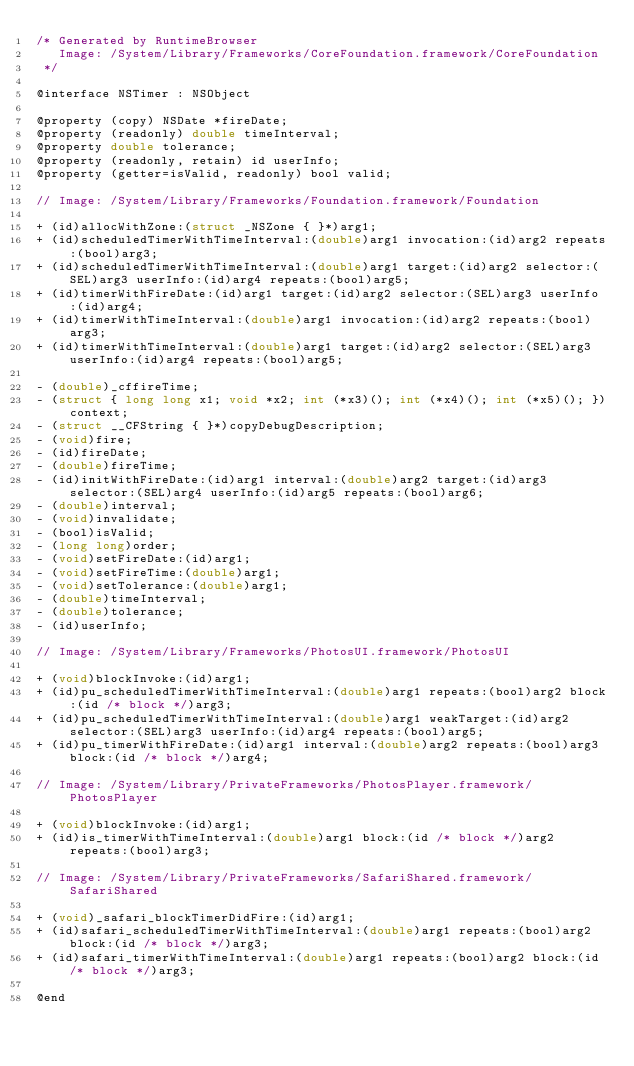<code> <loc_0><loc_0><loc_500><loc_500><_C_>/* Generated by RuntimeBrowser
   Image: /System/Library/Frameworks/CoreFoundation.framework/CoreFoundation
 */

@interface NSTimer : NSObject

@property (copy) NSDate *fireDate;
@property (readonly) double timeInterval;
@property double tolerance;
@property (readonly, retain) id userInfo;
@property (getter=isValid, readonly) bool valid;

// Image: /System/Library/Frameworks/Foundation.framework/Foundation

+ (id)allocWithZone:(struct _NSZone { }*)arg1;
+ (id)scheduledTimerWithTimeInterval:(double)arg1 invocation:(id)arg2 repeats:(bool)arg3;
+ (id)scheduledTimerWithTimeInterval:(double)arg1 target:(id)arg2 selector:(SEL)arg3 userInfo:(id)arg4 repeats:(bool)arg5;
+ (id)timerWithFireDate:(id)arg1 target:(id)arg2 selector:(SEL)arg3 userInfo:(id)arg4;
+ (id)timerWithTimeInterval:(double)arg1 invocation:(id)arg2 repeats:(bool)arg3;
+ (id)timerWithTimeInterval:(double)arg1 target:(id)arg2 selector:(SEL)arg3 userInfo:(id)arg4 repeats:(bool)arg5;

- (double)_cffireTime;
- (struct { long long x1; void *x2; int (*x3)(); int (*x4)(); int (*x5)(); })context;
- (struct __CFString { }*)copyDebugDescription;
- (void)fire;
- (id)fireDate;
- (double)fireTime;
- (id)initWithFireDate:(id)arg1 interval:(double)arg2 target:(id)arg3 selector:(SEL)arg4 userInfo:(id)arg5 repeats:(bool)arg6;
- (double)interval;
- (void)invalidate;
- (bool)isValid;
- (long long)order;
- (void)setFireDate:(id)arg1;
- (void)setFireTime:(double)arg1;
- (void)setTolerance:(double)arg1;
- (double)timeInterval;
- (double)tolerance;
- (id)userInfo;

// Image: /System/Library/Frameworks/PhotosUI.framework/PhotosUI

+ (void)blockInvoke:(id)arg1;
+ (id)pu_scheduledTimerWithTimeInterval:(double)arg1 repeats:(bool)arg2 block:(id /* block */)arg3;
+ (id)pu_scheduledTimerWithTimeInterval:(double)arg1 weakTarget:(id)arg2 selector:(SEL)arg3 userInfo:(id)arg4 repeats:(bool)arg5;
+ (id)pu_timerWithFireDate:(id)arg1 interval:(double)arg2 repeats:(bool)arg3 block:(id /* block */)arg4;

// Image: /System/Library/PrivateFrameworks/PhotosPlayer.framework/PhotosPlayer

+ (void)blockInvoke:(id)arg1;
+ (id)is_timerWithTimeInterval:(double)arg1 block:(id /* block */)arg2 repeats:(bool)arg3;

// Image: /System/Library/PrivateFrameworks/SafariShared.framework/SafariShared

+ (void)_safari_blockTimerDidFire:(id)arg1;
+ (id)safari_scheduledTimerWithTimeInterval:(double)arg1 repeats:(bool)arg2 block:(id /* block */)arg3;
+ (id)safari_timerWithTimeInterval:(double)arg1 repeats:(bool)arg2 block:(id /* block */)arg3;

@end
</code> 